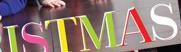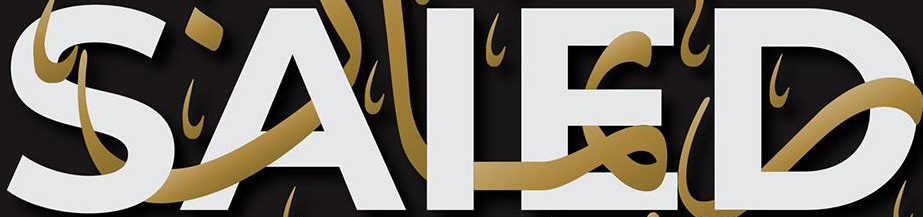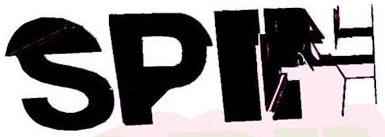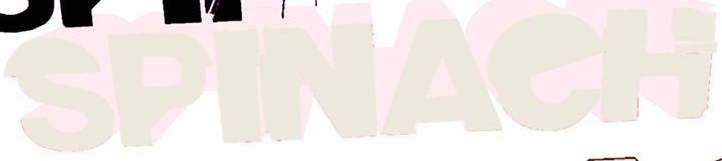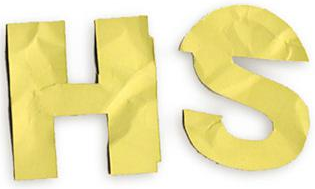What words can you see in these images in sequence, separated by a semicolon? ISTMAS; SAIED; SPIN; SPINAeH; HS 